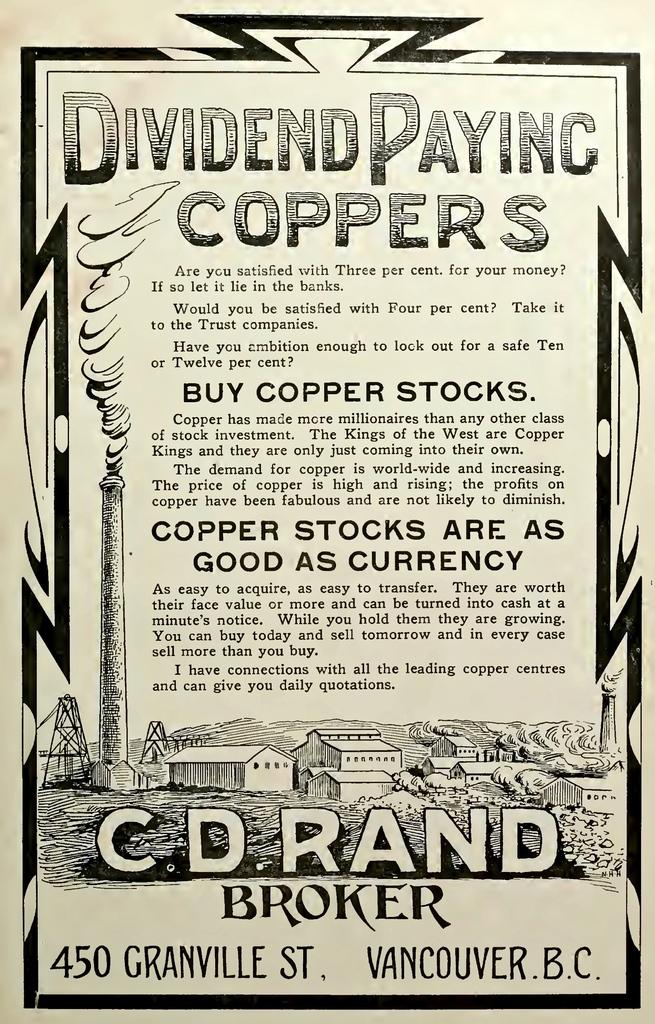What is featured in the image? There is a poster in the image. What can be found on the poster? The poster contains text and a painting. What type of beam is holding up the painting on the poster? There is no beam present in the image; it is a poster with text and a painting. What process is being depicted in the painting on the poster? The painting on the poster does not depict a process; it is a standalone image. 